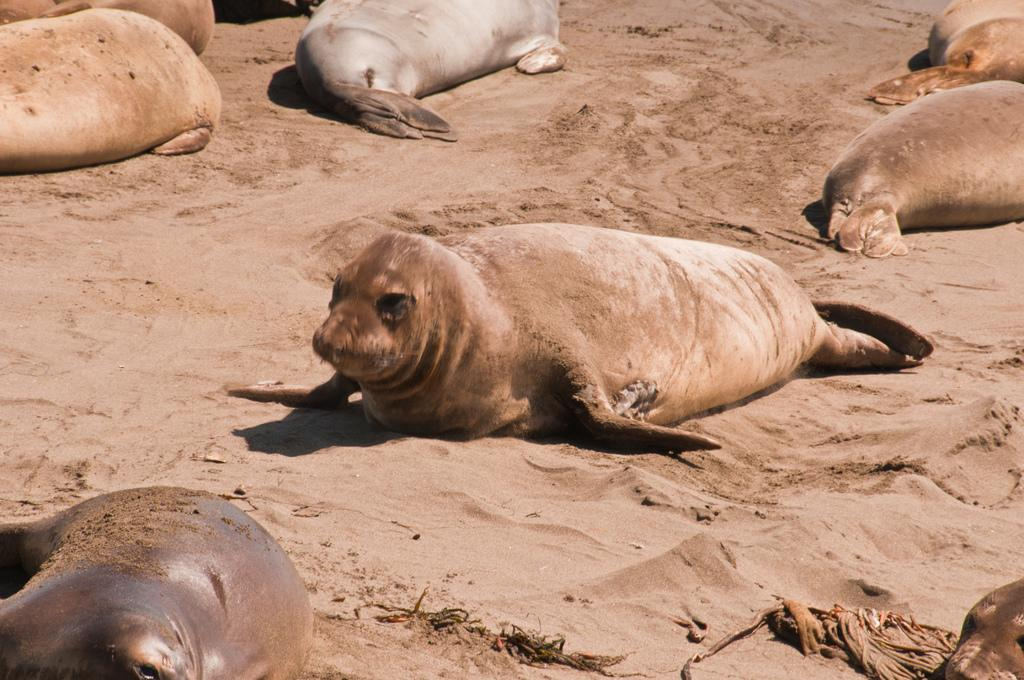What animals are present in the image? There are many seals in the image. Where are the seals located? The seals are on the sand. What type of tree can be seen growing in the sand with the seals? There is no tree present in the image; it only features seals on the sand. 